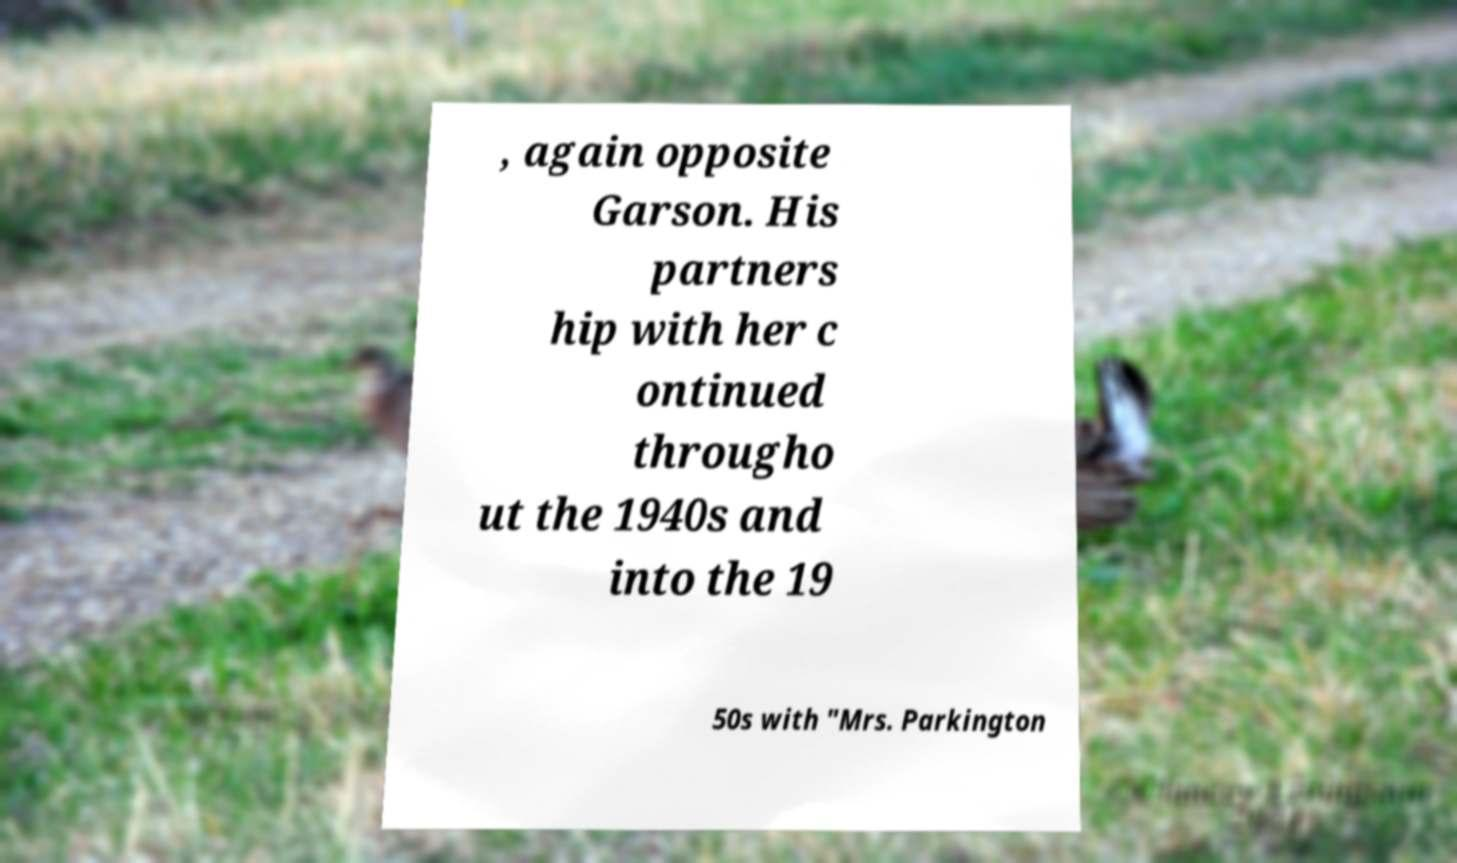Can you accurately transcribe the text from the provided image for me? , again opposite Garson. His partners hip with her c ontinued througho ut the 1940s and into the 19 50s with "Mrs. Parkington 